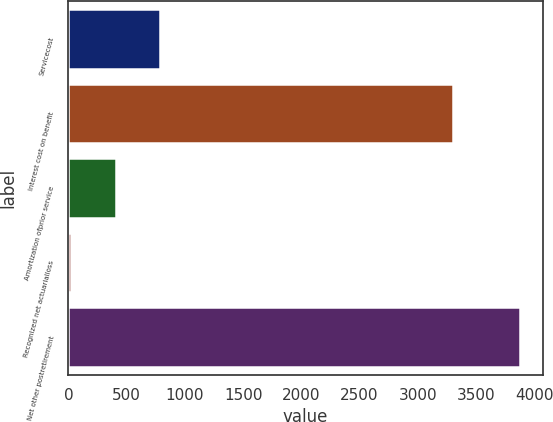<chart> <loc_0><loc_0><loc_500><loc_500><bar_chart><fcel>Servicecost<fcel>Interest cost on benefit<fcel>Amortization ofprior service<fcel>Recognized net actuarialloss<fcel>Net other postretirement<nl><fcel>791<fcel>3302<fcel>405<fcel>19<fcel>3879<nl></chart> 